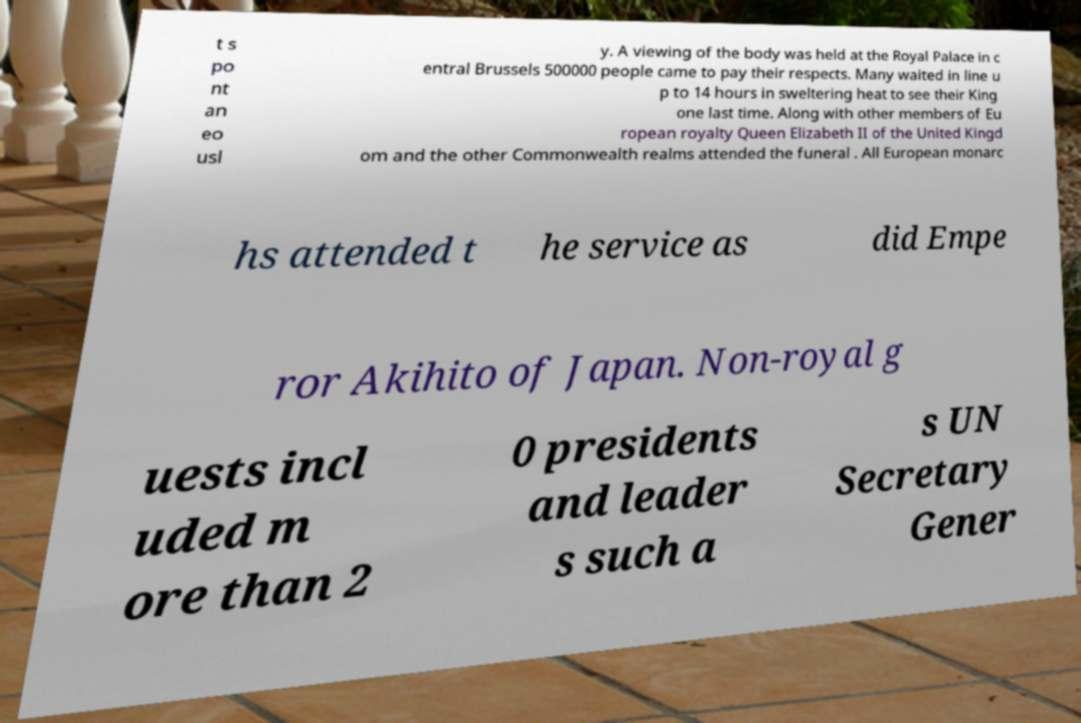Could you extract and type out the text from this image? t s po nt an eo usl y. A viewing of the body was held at the Royal Palace in c entral Brussels 500000 people came to pay their respects. Many waited in line u p to 14 hours in sweltering heat to see their King one last time. Along with other members of Eu ropean royalty Queen Elizabeth II of the United Kingd om and the other Commonwealth realms attended the funeral . All European monarc hs attended t he service as did Empe ror Akihito of Japan. Non-royal g uests incl uded m ore than 2 0 presidents and leader s such a s UN Secretary Gener 